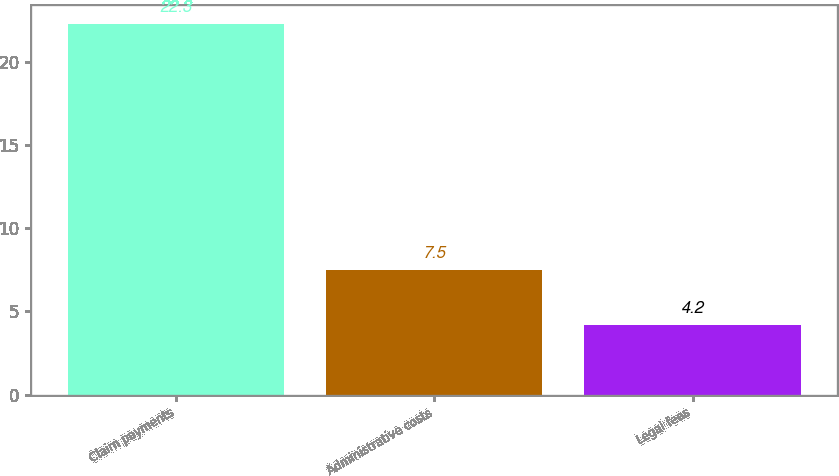Convert chart. <chart><loc_0><loc_0><loc_500><loc_500><bar_chart><fcel>Claim payments<fcel>Administrative costs<fcel>Legal fees<nl><fcel>22.3<fcel>7.5<fcel>4.2<nl></chart> 